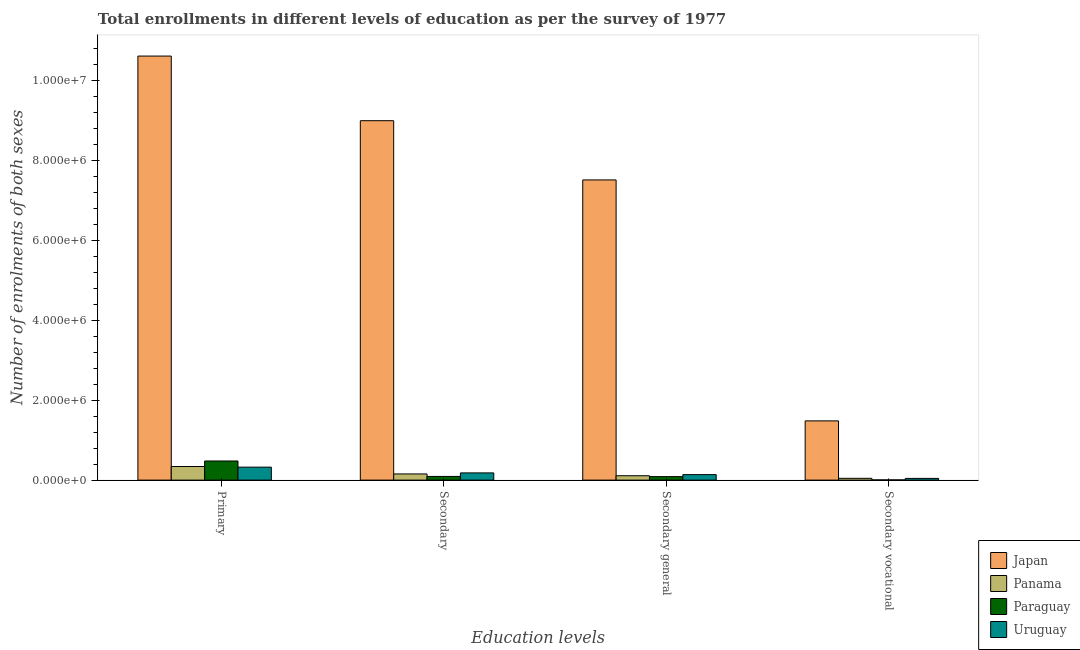How many different coloured bars are there?
Your answer should be compact. 4. How many groups of bars are there?
Make the answer very short. 4. Are the number of bars per tick equal to the number of legend labels?
Make the answer very short. Yes. How many bars are there on the 3rd tick from the right?
Ensure brevity in your answer.  4. What is the label of the 1st group of bars from the left?
Offer a terse response. Primary. What is the number of enrolments in primary education in Japan?
Your answer should be compact. 1.06e+07. Across all countries, what is the maximum number of enrolments in secondary vocational education?
Ensure brevity in your answer.  1.48e+06. Across all countries, what is the minimum number of enrolments in primary education?
Keep it short and to the point. 3.24e+05. In which country was the number of enrolments in primary education minimum?
Make the answer very short. Uruguay. What is the total number of enrolments in secondary general education in the graph?
Your response must be concise. 7.85e+06. What is the difference between the number of enrolments in secondary vocational education in Panama and that in Japan?
Your answer should be very brief. -1.44e+06. What is the difference between the number of enrolments in secondary general education in Uruguay and the number of enrolments in secondary education in Panama?
Your response must be concise. -1.71e+04. What is the average number of enrolments in secondary vocational education per country?
Your answer should be compact. 3.94e+05. What is the difference between the number of enrolments in secondary vocational education and number of enrolments in secondary education in Paraguay?
Your response must be concise. -8.70e+04. In how many countries, is the number of enrolments in primary education greater than 2400000 ?
Make the answer very short. 1. What is the ratio of the number of enrolments in secondary general education in Paraguay to that in Uruguay?
Your answer should be compact. 0.63. Is the difference between the number of enrolments in secondary general education in Uruguay and Panama greater than the difference between the number of enrolments in primary education in Uruguay and Panama?
Your response must be concise. Yes. What is the difference between the highest and the second highest number of enrolments in secondary vocational education?
Ensure brevity in your answer.  1.44e+06. What is the difference between the highest and the lowest number of enrolments in primary education?
Provide a short and direct response. 1.03e+07. In how many countries, is the number of enrolments in secondary education greater than the average number of enrolments in secondary education taken over all countries?
Offer a terse response. 1. Is the sum of the number of enrolments in primary education in Paraguay and Panama greater than the maximum number of enrolments in secondary general education across all countries?
Offer a very short reply. No. Is it the case that in every country, the sum of the number of enrolments in primary education and number of enrolments in secondary general education is greater than the sum of number of enrolments in secondary vocational education and number of enrolments in secondary education?
Your answer should be compact. No. What does the 2nd bar from the left in Secondary general represents?
Ensure brevity in your answer.  Panama. What does the 2nd bar from the right in Secondary represents?
Give a very brief answer. Paraguay. Is it the case that in every country, the sum of the number of enrolments in primary education and number of enrolments in secondary education is greater than the number of enrolments in secondary general education?
Offer a very short reply. Yes. Are all the bars in the graph horizontal?
Provide a succinct answer. No. How many countries are there in the graph?
Offer a very short reply. 4. Are the values on the major ticks of Y-axis written in scientific E-notation?
Make the answer very short. Yes. How many legend labels are there?
Offer a very short reply. 4. What is the title of the graph?
Your answer should be compact. Total enrollments in different levels of education as per the survey of 1977. Does "Pakistan" appear as one of the legend labels in the graph?
Your answer should be compact. No. What is the label or title of the X-axis?
Make the answer very short. Education levels. What is the label or title of the Y-axis?
Offer a very short reply. Number of enrolments of both sexes. What is the Number of enrolments of both sexes in Japan in Primary?
Provide a succinct answer. 1.06e+07. What is the Number of enrolments of both sexes of Panama in Primary?
Provide a succinct answer. 3.41e+05. What is the Number of enrolments of both sexes of Paraguay in Primary?
Your response must be concise. 4.79e+05. What is the Number of enrolments of both sexes in Uruguay in Primary?
Your response must be concise. 3.24e+05. What is the Number of enrolments of both sexes in Japan in Secondary?
Your answer should be very brief. 8.99e+06. What is the Number of enrolments of both sexes of Panama in Secondary?
Offer a terse response. 1.54e+05. What is the Number of enrolments of both sexes in Paraguay in Secondary?
Provide a succinct answer. 9.24e+04. What is the Number of enrolments of both sexes in Uruguay in Secondary?
Your answer should be compact. 1.80e+05. What is the Number of enrolments of both sexes of Japan in Secondary general?
Provide a short and direct response. 7.51e+06. What is the Number of enrolments of both sexes of Panama in Secondary general?
Ensure brevity in your answer.  1.10e+05. What is the Number of enrolments of both sexes in Paraguay in Secondary general?
Your response must be concise. 8.70e+04. What is the Number of enrolments of both sexes of Uruguay in Secondary general?
Your answer should be very brief. 1.37e+05. What is the Number of enrolments of both sexes of Japan in Secondary vocational?
Your answer should be very brief. 1.48e+06. What is the Number of enrolments of both sexes of Panama in Secondary vocational?
Offer a terse response. 4.48e+04. What is the Number of enrolments of both sexes of Paraguay in Secondary vocational?
Provide a succinct answer. 5427. What is the Number of enrolments of both sexes in Uruguay in Secondary vocational?
Your answer should be compact. 4.31e+04. Across all Education levels, what is the maximum Number of enrolments of both sexes in Japan?
Provide a succinct answer. 1.06e+07. Across all Education levels, what is the maximum Number of enrolments of both sexes of Panama?
Your response must be concise. 3.41e+05. Across all Education levels, what is the maximum Number of enrolments of both sexes in Paraguay?
Your response must be concise. 4.79e+05. Across all Education levels, what is the maximum Number of enrolments of both sexes of Uruguay?
Give a very brief answer. 3.24e+05. Across all Education levels, what is the minimum Number of enrolments of both sexes of Japan?
Provide a succinct answer. 1.48e+06. Across all Education levels, what is the minimum Number of enrolments of both sexes of Panama?
Keep it short and to the point. 4.48e+04. Across all Education levels, what is the minimum Number of enrolments of both sexes of Paraguay?
Make the answer very short. 5427. Across all Education levels, what is the minimum Number of enrolments of both sexes of Uruguay?
Provide a short and direct response. 4.31e+04. What is the total Number of enrolments of both sexes in Japan in the graph?
Ensure brevity in your answer.  2.86e+07. What is the total Number of enrolments of both sexes of Panama in the graph?
Give a very brief answer. 6.49e+05. What is the total Number of enrolments of both sexes in Paraguay in the graph?
Offer a very short reply. 6.63e+05. What is the total Number of enrolments of both sexes of Uruguay in the graph?
Your response must be concise. 6.85e+05. What is the difference between the Number of enrolments of both sexes of Japan in Primary and that in Secondary?
Make the answer very short. 1.62e+06. What is the difference between the Number of enrolments of both sexes of Panama in Primary and that in Secondary?
Provide a succinct answer. 1.86e+05. What is the difference between the Number of enrolments of both sexes in Paraguay in Primary and that in Secondary?
Provide a short and direct response. 3.86e+05. What is the difference between the Number of enrolments of both sexes of Uruguay in Primary and that in Secondary?
Give a very brief answer. 1.44e+05. What is the difference between the Number of enrolments of both sexes in Japan in Primary and that in Secondary general?
Make the answer very short. 3.10e+06. What is the difference between the Number of enrolments of both sexes of Panama in Primary and that in Secondary general?
Offer a terse response. 2.31e+05. What is the difference between the Number of enrolments of both sexes of Paraguay in Primary and that in Secondary general?
Offer a terse response. 3.92e+05. What is the difference between the Number of enrolments of both sexes in Uruguay in Primary and that in Secondary general?
Ensure brevity in your answer.  1.87e+05. What is the difference between the Number of enrolments of both sexes in Japan in Primary and that in Secondary vocational?
Offer a very short reply. 9.13e+06. What is the difference between the Number of enrolments of both sexes in Panama in Primary and that in Secondary vocational?
Your response must be concise. 2.96e+05. What is the difference between the Number of enrolments of both sexes in Paraguay in Primary and that in Secondary vocational?
Your answer should be compact. 4.73e+05. What is the difference between the Number of enrolments of both sexes in Uruguay in Primary and that in Secondary vocational?
Your response must be concise. 2.81e+05. What is the difference between the Number of enrolments of both sexes of Japan in Secondary and that in Secondary general?
Make the answer very short. 1.48e+06. What is the difference between the Number of enrolments of both sexes in Panama in Secondary and that in Secondary general?
Offer a terse response. 4.48e+04. What is the difference between the Number of enrolments of both sexes of Paraguay in Secondary and that in Secondary general?
Provide a short and direct response. 5427. What is the difference between the Number of enrolments of both sexes of Uruguay in Secondary and that in Secondary general?
Offer a terse response. 4.31e+04. What is the difference between the Number of enrolments of both sexes of Japan in Secondary and that in Secondary vocational?
Provide a succinct answer. 7.51e+06. What is the difference between the Number of enrolments of both sexes of Panama in Secondary and that in Secondary vocational?
Your response must be concise. 1.10e+05. What is the difference between the Number of enrolments of both sexes in Paraguay in Secondary and that in Secondary vocational?
Offer a terse response. 8.70e+04. What is the difference between the Number of enrolments of both sexes of Uruguay in Secondary and that in Secondary vocational?
Your response must be concise. 1.37e+05. What is the difference between the Number of enrolments of both sexes in Japan in Secondary general and that in Secondary vocational?
Provide a short and direct response. 6.03e+06. What is the difference between the Number of enrolments of both sexes of Panama in Secondary general and that in Secondary vocational?
Your answer should be very brief. 6.48e+04. What is the difference between the Number of enrolments of both sexes in Paraguay in Secondary general and that in Secondary vocational?
Give a very brief answer. 8.16e+04. What is the difference between the Number of enrolments of both sexes in Uruguay in Secondary general and that in Secondary vocational?
Your response must be concise. 9.42e+04. What is the difference between the Number of enrolments of both sexes of Japan in Primary and the Number of enrolments of both sexes of Panama in Secondary?
Offer a terse response. 1.05e+07. What is the difference between the Number of enrolments of both sexes of Japan in Primary and the Number of enrolments of both sexes of Paraguay in Secondary?
Your answer should be very brief. 1.05e+07. What is the difference between the Number of enrolments of both sexes of Japan in Primary and the Number of enrolments of both sexes of Uruguay in Secondary?
Give a very brief answer. 1.04e+07. What is the difference between the Number of enrolments of both sexes of Panama in Primary and the Number of enrolments of both sexes of Paraguay in Secondary?
Offer a very short reply. 2.48e+05. What is the difference between the Number of enrolments of both sexes of Panama in Primary and the Number of enrolments of both sexes of Uruguay in Secondary?
Keep it short and to the point. 1.60e+05. What is the difference between the Number of enrolments of both sexes of Paraguay in Primary and the Number of enrolments of both sexes of Uruguay in Secondary?
Your response must be concise. 2.98e+05. What is the difference between the Number of enrolments of both sexes in Japan in Primary and the Number of enrolments of both sexes in Panama in Secondary general?
Your answer should be compact. 1.05e+07. What is the difference between the Number of enrolments of both sexes in Japan in Primary and the Number of enrolments of both sexes in Paraguay in Secondary general?
Provide a succinct answer. 1.05e+07. What is the difference between the Number of enrolments of both sexes of Japan in Primary and the Number of enrolments of both sexes of Uruguay in Secondary general?
Your answer should be very brief. 1.05e+07. What is the difference between the Number of enrolments of both sexes of Panama in Primary and the Number of enrolments of both sexes of Paraguay in Secondary general?
Keep it short and to the point. 2.54e+05. What is the difference between the Number of enrolments of both sexes in Panama in Primary and the Number of enrolments of both sexes in Uruguay in Secondary general?
Ensure brevity in your answer.  2.03e+05. What is the difference between the Number of enrolments of both sexes in Paraguay in Primary and the Number of enrolments of both sexes in Uruguay in Secondary general?
Give a very brief answer. 3.41e+05. What is the difference between the Number of enrolments of both sexes of Japan in Primary and the Number of enrolments of both sexes of Panama in Secondary vocational?
Offer a terse response. 1.06e+07. What is the difference between the Number of enrolments of both sexes of Japan in Primary and the Number of enrolments of both sexes of Paraguay in Secondary vocational?
Offer a terse response. 1.06e+07. What is the difference between the Number of enrolments of both sexes in Japan in Primary and the Number of enrolments of both sexes in Uruguay in Secondary vocational?
Give a very brief answer. 1.06e+07. What is the difference between the Number of enrolments of both sexes in Panama in Primary and the Number of enrolments of both sexes in Paraguay in Secondary vocational?
Offer a terse response. 3.35e+05. What is the difference between the Number of enrolments of both sexes of Panama in Primary and the Number of enrolments of both sexes of Uruguay in Secondary vocational?
Your answer should be compact. 2.97e+05. What is the difference between the Number of enrolments of both sexes in Paraguay in Primary and the Number of enrolments of both sexes in Uruguay in Secondary vocational?
Make the answer very short. 4.35e+05. What is the difference between the Number of enrolments of both sexes in Japan in Secondary and the Number of enrolments of both sexes in Panama in Secondary general?
Ensure brevity in your answer.  8.88e+06. What is the difference between the Number of enrolments of both sexes in Japan in Secondary and the Number of enrolments of both sexes in Paraguay in Secondary general?
Ensure brevity in your answer.  8.91e+06. What is the difference between the Number of enrolments of both sexes of Japan in Secondary and the Number of enrolments of both sexes of Uruguay in Secondary general?
Your answer should be very brief. 8.86e+06. What is the difference between the Number of enrolments of both sexes in Panama in Secondary and the Number of enrolments of both sexes in Paraguay in Secondary general?
Ensure brevity in your answer.  6.74e+04. What is the difference between the Number of enrolments of both sexes of Panama in Secondary and the Number of enrolments of both sexes of Uruguay in Secondary general?
Your answer should be very brief. 1.71e+04. What is the difference between the Number of enrolments of both sexes in Paraguay in Secondary and the Number of enrolments of both sexes in Uruguay in Secondary general?
Give a very brief answer. -4.49e+04. What is the difference between the Number of enrolments of both sexes in Japan in Secondary and the Number of enrolments of both sexes in Panama in Secondary vocational?
Offer a terse response. 8.95e+06. What is the difference between the Number of enrolments of both sexes in Japan in Secondary and the Number of enrolments of both sexes in Paraguay in Secondary vocational?
Offer a very short reply. 8.99e+06. What is the difference between the Number of enrolments of both sexes in Japan in Secondary and the Number of enrolments of both sexes in Uruguay in Secondary vocational?
Your answer should be compact. 8.95e+06. What is the difference between the Number of enrolments of both sexes in Panama in Secondary and the Number of enrolments of both sexes in Paraguay in Secondary vocational?
Provide a succinct answer. 1.49e+05. What is the difference between the Number of enrolments of both sexes of Panama in Secondary and the Number of enrolments of both sexes of Uruguay in Secondary vocational?
Give a very brief answer. 1.11e+05. What is the difference between the Number of enrolments of both sexes in Paraguay in Secondary and the Number of enrolments of both sexes in Uruguay in Secondary vocational?
Provide a short and direct response. 4.93e+04. What is the difference between the Number of enrolments of both sexes of Japan in Secondary general and the Number of enrolments of both sexes of Panama in Secondary vocational?
Ensure brevity in your answer.  7.47e+06. What is the difference between the Number of enrolments of both sexes in Japan in Secondary general and the Number of enrolments of both sexes in Paraguay in Secondary vocational?
Offer a terse response. 7.51e+06. What is the difference between the Number of enrolments of both sexes of Japan in Secondary general and the Number of enrolments of both sexes of Uruguay in Secondary vocational?
Your answer should be compact. 7.47e+06. What is the difference between the Number of enrolments of both sexes in Panama in Secondary general and the Number of enrolments of both sexes in Paraguay in Secondary vocational?
Ensure brevity in your answer.  1.04e+05. What is the difference between the Number of enrolments of both sexes in Panama in Secondary general and the Number of enrolments of both sexes in Uruguay in Secondary vocational?
Offer a very short reply. 6.65e+04. What is the difference between the Number of enrolments of both sexes in Paraguay in Secondary general and the Number of enrolments of both sexes in Uruguay in Secondary vocational?
Give a very brief answer. 4.39e+04. What is the average Number of enrolments of both sexes of Japan per Education levels?
Provide a short and direct response. 7.15e+06. What is the average Number of enrolments of both sexes of Panama per Education levels?
Your response must be concise. 1.62e+05. What is the average Number of enrolments of both sexes of Paraguay per Education levels?
Offer a very short reply. 1.66e+05. What is the average Number of enrolments of both sexes in Uruguay per Education levels?
Your answer should be compact. 1.71e+05. What is the difference between the Number of enrolments of both sexes of Japan and Number of enrolments of both sexes of Panama in Primary?
Provide a short and direct response. 1.03e+07. What is the difference between the Number of enrolments of both sexes in Japan and Number of enrolments of both sexes in Paraguay in Primary?
Offer a very short reply. 1.01e+07. What is the difference between the Number of enrolments of both sexes in Japan and Number of enrolments of both sexes in Uruguay in Primary?
Your answer should be very brief. 1.03e+07. What is the difference between the Number of enrolments of both sexes in Panama and Number of enrolments of both sexes in Paraguay in Primary?
Your response must be concise. -1.38e+05. What is the difference between the Number of enrolments of both sexes of Panama and Number of enrolments of both sexes of Uruguay in Primary?
Ensure brevity in your answer.  1.62e+04. What is the difference between the Number of enrolments of both sexes of Paraguay and Number of enrolments of both sexes of Uruguay in Primary?
Offer a very short reply. 1.54e+05. What is the difference between the Number of enrolments of both sexes of Japan and Number of enrolments of both sexes of Panama in Secondary?
Your response must be concise. 8.84e+06. What is the difference between the Number of enrolments of both sexes of Japan and Number of enrolments of both sexes of Paraguay in Secondary?
Keep it short and to the point. 8.90e+06. What is the difference between the Number of enrolments of both sexes of Japan and Number of enrolments of both sexes of Uruguay in Secondary?
Provide a succinct answer. 8.81e+06. What is the difference between the Number of enrolments of both sexes in Panama and Number of enrolments of both sexes in Paraguay in Secondary?
Make the answer very short. 6.20e+04. What is the difference between the Number of enrolments of both sexes in Panama and Number of enrolments of both sexes in Uruguay in Secondary?
Provide a short and direct response. -2.60e+04. What is the difference between the Number of enrolments of both sexes in Paraguay and Number of enrolments of both sexes in Uruguay in Secondary?
Ensure brevity in your answer.  -8.80e+04. What is the difference between the Number of enrolments of both sexes of Japan and Number of enrolments of both sexes of Panama in Secondary general?
Give a very brief answer. 7.40e+06. What is the difference between the Number of enrolments of both sexes in Japan and Number of enrolments of both sexes in Paraguay in Secondary general?
Give a very brief answer. 7.42e+06. What is the difference between the Number of enrolments of both sexes of Japan and Number of enrolments of both sexes of Uruguay in Secondary general?
Provide a short and direct response. 7.37e+06. What is the difference between the Number of enrolments of both sexes of Panama and Number of enrolments of both sexes of Paraguay in Secondary general?
Provide a succinct answer. 2.26e+04. What is the difference between the Number of enrolments of both sexes of Panama and Number of enrolments of both sexes of Uruguay in Secondary general?
Ensure brevity in your answer.  -2.77e+04. What is the difference between the Number of enrolments of both sexes of Paraguay and Number of enrolments of both sexes of Uruguay in Secondary general?
Make the answer very short. -5.03e+04. What is the difference between the Number of enrolments of both sexes of Japan and Number of enrolments of both sexes of Panama in Secondary vocational?
Offer a terse response. 1.44e+06. What is the difference between the Number of enrolments of both sexes of Japan and Number of enrolments of both sexes of Paraguay in Secondary vocational?
Make the answer very short. 1.48e+06. What is the difference between the Number of enrolments of both sexes of Japan and Number of enrolments of both sexes of Uruguay in Secondary vocational?
Your answer should be very brief. 1.44e+06. What is the difference between the Number of enrolments of both sexes of Panama and Number of enrolments of both sexes of Paraguay in Secondary vocational?
Offer a very short reply. 3.94e+04. What is the difference between the Number of enrolments of both sexes of Panama and Number of enrolments of both sexes of Uruguay in Secondary vocational?
Give a very brief answer. 1719. What is the difference between the Number of enrolments of both sexes of Paraguay and Number of enrolments of both sexes of Uruguay in Secondary vocational?
Your response must be concise. -3.77e+04. What is the ratio of the Number of enrolments of both sexes of Japan in Primary to that in Secondary?
Ensure brevity in your answer.  1.18. What is the ratio of the Number of enrolments of both sexes in Panama in Primary to that in Secondary?
Provide a short and direct response. 2.21. What is the ratio of the Number of enrolments of both sexes of Paraguay in Primary to that in Secondary?
Keep it short and to the point. 5.18. What is the ratio of the Number of enrolments of both sexes of Uruguay in Primary to that in Secondary?
Give a very brief answer. 1.8. What is the ratio of the Number of enrolments of both sexes of Japan in Primary to that in Secondary general?
Provide a short and direct response. 1.41. What is the ratio of the Number of enrolments of both sexes of Panama in Primary to that in Secondary general?
Ensure brevity in your answer.  3.11. What is the ratio of the Number of enrolments of both sexes in Paraguay in Primary to that in Secondary general?
Offer a very short reply. 5.5. What is the ratio of the Number of enrolments of both sexes in Uruguay in Primary to that in Secondary general?
Make the answer very short. 2.36. What is the ratio of the Number of enrolments of both sexes of Japan in Primary to that in Secondary vocational?
Provide a succinct answer. 7.16. What is the ratio of the Number of enrolments of both sexes in Panama in Primary to that in Secondary vocational?
Offer a terse response. 7.6. What is the ratio of the Number of enrolments of both sexes of Paraguay in Primary to that in Secondary vocational?
Offer a terse response. 88.19. What is the ratio of the Number of enrolments of both sexes of Uruguay in Primary to that in Secondary vocational?
Offer a terse response. 7.53. What is the ratio of the Number of enrolments of both sexes of Japan in Secondary to that in Secondary general?
Provide a short and direct response. 1.2. What is the ratio of the Number of enrolments of both sexes in Panama in Secondary to that in Secondary general?
Your answer should be compact. 1.41. What is the ratio of the Number of enrolments of both sexes in Paraguay in Secondary to that in Secondary general?
Your answer should be compact. 1.06. What is the ratio of the Number of enrolments of both sexes in Uruguay in Secondary to that in Secondary general?
Provide a short and direct response. 1.31. What is the ratio of the Number of enrolments of both sexes in Japan in Secondary to that in Secondary vocational?
Give a very brief answer. 6.07. What is the ratio of the Number of enrolments of both sexes of Panama in Secondary to that in Secondary vocational?
Offer a terse response. 3.45. What is the ratio of the Number of enrolments of both sexes of Paraguay in Secondary to that in Secondary vocational?
Offer a very short reply. 17.03. What is the ratio of the Number of enrolments of both sexes of Uruguay in Secondary to that in Secondary vocational?
Your answer should be compact. 4.19. What is the ratio of the Number of enrolments of both sexes of Japan in Secondary general to that in Secondary vocational?
Offer a terse response. 5.07. What is the ratio of the Number of enrolments of both sexes in Panama in Secondary general to that in Secondary vocational?
Your answer should be compact. 2.45. What is the ratio of the Number of enrolments of both sexes in Paraguay in Secondary general to that in Secondary vocational?
Offer a very short reply. 16.03. What is the ratio of the Number of enrolments of both sexes of Uruguay in Secondary general to that in Secondary vocational?
Ensure brevity in your answer.  3.19. What is the difference between the highest and the second highest Number of enrolments of both sexes of Japan?
Your answer should be very brief. 1.62e+06. What is the difference between the highest and the second highest Number of enrolments of both sexes in Panama?
Give a very brief answer. 1.86e+05. What is the difference between the highest and the second highest Number of enrolments of both sexes in Paraguay?
Make the answer very short. 3.86e+05. What is the difference between the highest and the second highest Number of enrolments of both sexes of Uruguay?
Keep it short and to the point. 1.44e+05. What is the difference between the highest and the lowest Number of enrolments of both sexes of Japan?
Provide a succinct answer. 9.13e+06. What is the difference between the highest and the lowest Number of enrolments of both sexes in Panama?
Keep it short and to the point. 2.96e+05. What is the difference between the highest and the lowest Number of enrolments of both sexes of Paraguay?
Ensure brevity in your answer.  4.73e+05. What is the difference between the highest and the lowest Number of enrolments of both sexes of Uruguay?
Your response must be concise. 2.81e+05. 